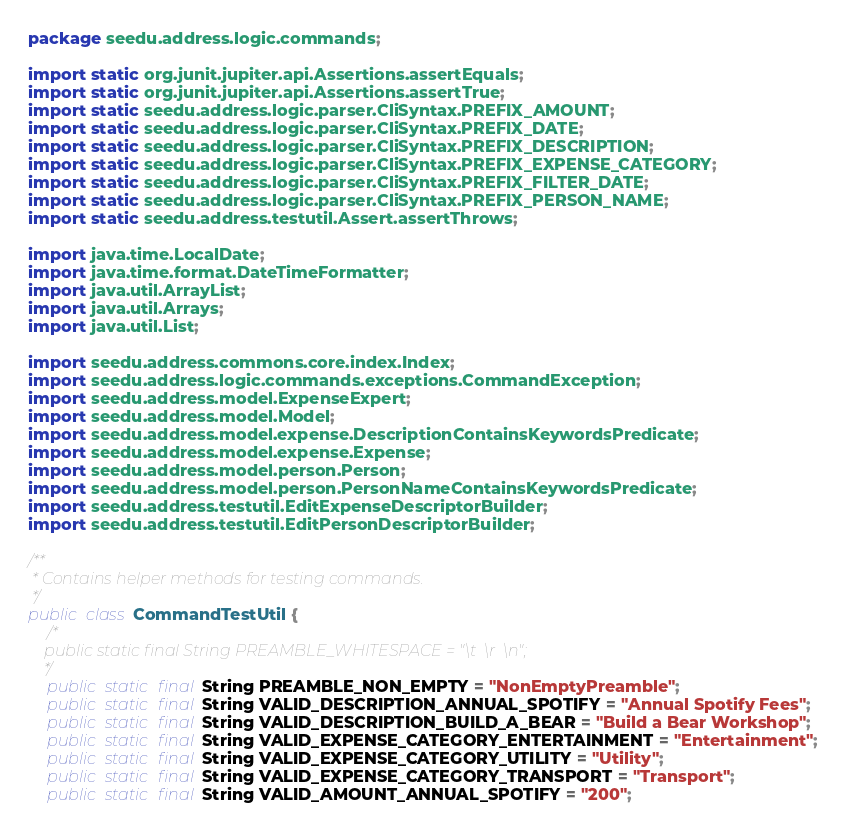<code> <loc_0><loc_0><loc_500><loc_500><_Java_>package seedu.address.logic.commands;

import static org.junit.jupiter.api.Assertions.assertEquals;
import static org.junit.jupiter.api.Assertions.assertTrue;
import static seedu.address.logic.parser.CliSyntax.PREFIX_AMOUNT;
import static seedu.address.logic.parser.CliSyntax.PREFIX_DATE;
import static seedu.address.logic.parser.CliSyntax.PREFIX_DESCRIPTION;
import static seedu.address.logic.parser.CliSyntax.PREFIX_EXPENSE_CATEGORY;
import static seedu.address.logic.parser.CliSyntax.PREFIX_FILTER_DATE;
import static seedu.address.logic.parser.CliSyntax.PREFIX_PERSON_NAME;
import static seedu.address.testutil.Assert.assertThrows;

import java.time.LocalDate;
import java.time.format.DateTimeFormatter;
import java.util.ArrayList;
import java.util.Arrays;
import java.util.List;

import seedu.address.commons.core.index.Index;
import seedu.address.logic.commands.exceptions.CommandException;
import seedu.address.model.ExpenseExpert;
import seedu.address.model.Model;
import seedu.address.model.expense.DescriptionContainsKeywordsPredicate;
import seedu.address.model.expense.Expense;
import seedu.address.model.person.Person;
import seedu.address.model.person.PersonNameContainsKeywordsPredicate;
import seedu.address.testutil.EditExpenseDescriptorBuilder;
import seedu.address.testutil.EditPersonDescriptorBuilder;

/**
 * Contains helper methods for testing commands.
 */
public class CommandTestUtil {
    /*
    public static final String PREAMBLE_WHITESPACE = "\t  \r  \n";
    */
    public static final String PREAMBLE_NON_EMPTY = "NonEmptyPreamble";
    public static final String VALID_DESCRIPTION_ANNUAL_SPOTIFY = "Annual Spotify Fees";
    public static final String VALID_DESCRIPTION_BUILD_A_BEAR = "Build a Bear Workshop";
    public static final String VALID_EXPENSE_CATEGORY_ENTERTAINMENT = "Entertainment";
    public static final String VALID_EXPENSE_CATEGORY_UTILITY = "Utility";
    public static final String VALID_EXPENSE_CATEGORY_TRANSPORT = "Transport";
    public static final String VALID_AMOUNT_ANNUAL_SPOTIFY = "200";</code> 